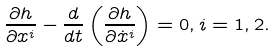<formula> <loc_0><loc_0><loc_500><loc_500>\frac { \partial h } { \partial x ^ { i } } - \frac { d } { d t } \left ( \frac { \partial h } { \partial \dot { x } ^ { i } } \right ) = 0 , i = 1 , 2 .</formula> 